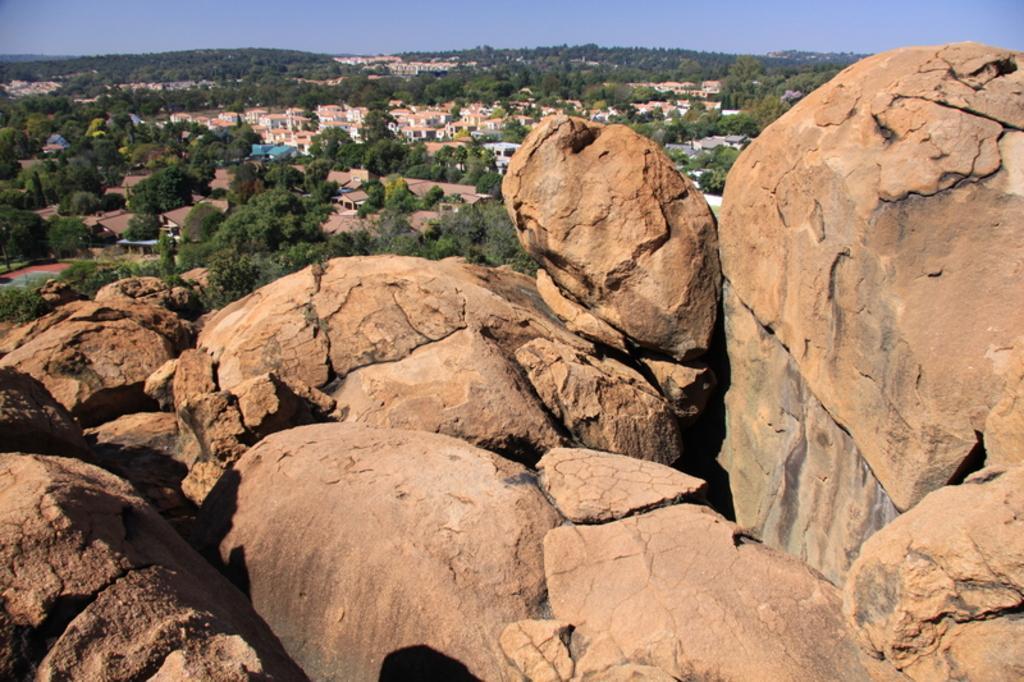Could you give a brief overview of what you see in this image? In the background we can see the sky. In this picture we can see buildings, trees, rooftops and mountains. 